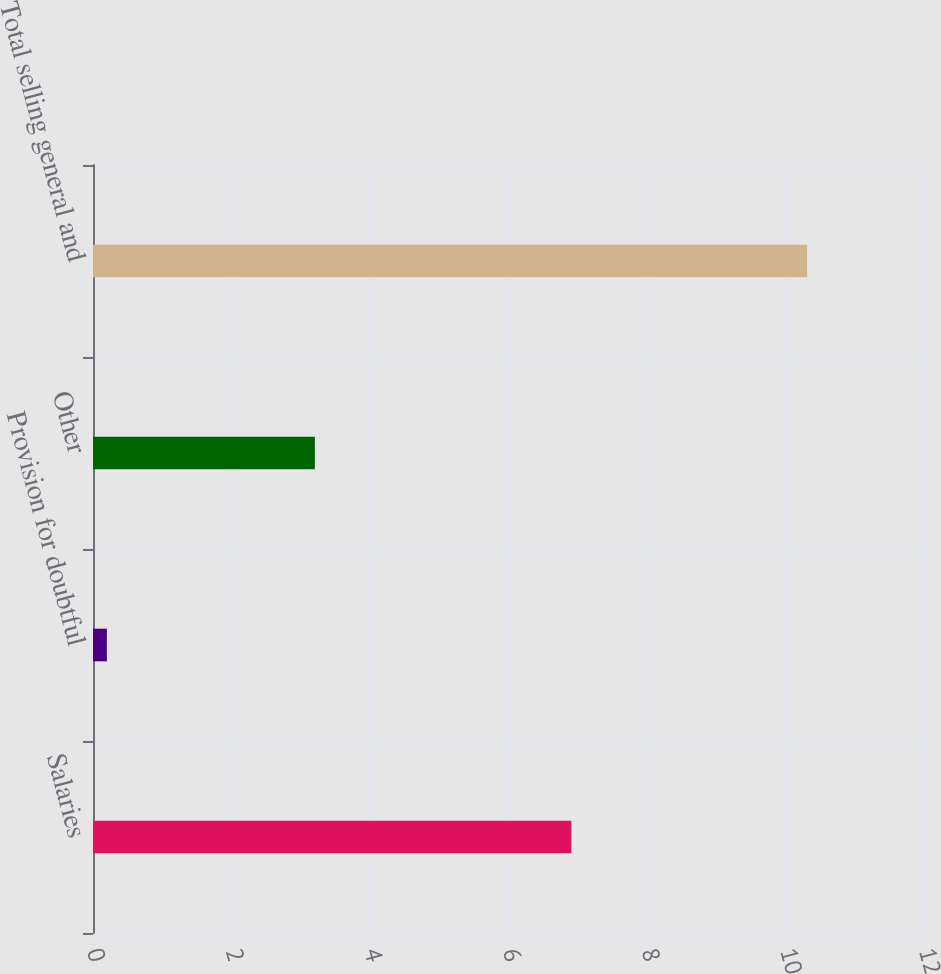<chart> <loc_0><loc_0><loc_500><loc_500><bar_chart><fcel>Salaries<fcel>Provision for doubtful<fcel>Other<fcel>Total selling general and<nl><fcel>6.9<fcel>0.2<fcel>3.2<fcel>10.3<nl></chart> 